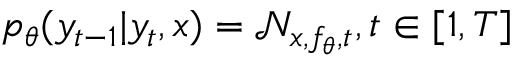<formula> <loc_0><loc_0><loc_500><loc_500>p _ { \theta } ( y _ { t - 1 } | y _ { t } , x ) = \mathcal { N } _ { x , f _ { \theta } , t } , t \in [ 1 , T ]</formula> 